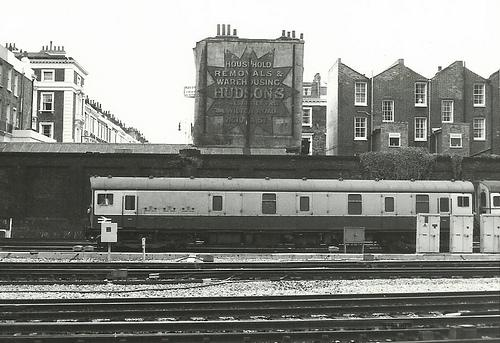Provide a brief description of the main objects in the image. The image depicts a train on rail tracks, with buildings in the background, an advertisement billboard and various windows, all in a black and white setting. Explain the object interactions in the image. The train interacts with the rail tracks on the ground and is surrounded by various buildings, which together create an urban scene with a nostalgic vibe. Describe the advertisement in the image. The advertisement is a large, faded billboard-type sign on the side of a building. It appears to be worn out, giving the image an old-fashioned feel. What is the sentiment of the image, and give a reason for your answer. The image has a nostalgic sentiment as it contains an old passenger train, rusty metal tracks, and worn-out advertisement, all set in the context of a black and white photograph. How many townhomes can you observe in the background? There is a row of townhomes in the background, comprising a housing complex. Describe the sky and ground in the image. The sky is a crisp white, possibly with clouds, while the ground is covered in light gray gravel. Mention the features of the train in the image. The train is two-toned, has round-edged windows, wheels, and a black roof. It is parked on rusty metal tracks, and appears to be an old passenger train. Count the number of train cars visible in the image. There are two train cars visible on the tracks in the image. Can you identify any specific structures in the background? There is a housing complex, a multi-story brick building, an edifice, and various other buildings in the background. Some of these structures also have chimneys. State the colors present in the image. The image is in black and white, which adds a monochromatic tone to the objects and scenery. Is the train on the rail green and red? The image is black and white, so it's impossible to determine the color of the train. How many power boxes can you spot in the image? three What color scheme does the photo have? black and white What is the state of the advertisement on the side of the building? worn out, large, faded billboard type advertisement Describe the ground surface in the image. light gray gravel Is there any ongoing activity in the scene? train is going through the city Describe the train in the image. old passenger train, two toned, parked on rusty metal tracks What additional details can be found on the train and train tracks? wheels on the train, roof of the train, small metal item by tracks Does the door with a window have a pink frame? The image is black and white, so it's impossible to determine the color of the door frame. How many train cars are visible on the track? two Which of the following can you see in the image: train, car, bike, or airplane? train Identify any text or words present in the image. advertisements on a building Is the sky filled with colorful balloons? The image is black and white, and there is no mention of balloons in the captions, so it's not possible to determine if there are any balloons in the sky. Describe any weather or visible atmospheric conditions in the image. cloudy sky What are the windows on the side of the train like? row of round-edged windows Are there any animals visible on the train tracks? There is no mention of animals in the captions, so it's unlikely that any animals are visible in the image. Are the wheels on the train square-shaped? It is highly unlikely for a train to have square-shaped wheels, as they are typically round for smooth motion on the tracks. Explain the types of buildings visible in the scene. multi-story brick buildings, edifice, housing complex, old building by train tracks Describe the sky in the image. cloudy and crisp white Is the factory above the train producing smoke? There is no mention of smoke in the captions, so it's not possible to determine if the factory is producing smoke. Imagine an advertisement for this old passenger train. What images and text would you choose to create an engaging advertisement? Image of train in motion, text: "Experience the nostalgia of the past with our charming old passenger train." What specific types of windows can be seen on the buildings? rectangle windows, chimneys on top Identify a main event happening in the photo. Train going through the city. Decode the structure of the train tracks and how they are arranged. numerous train tracks in a row on light gray gravel ground What type of emotion can be read from the picture? N/A 